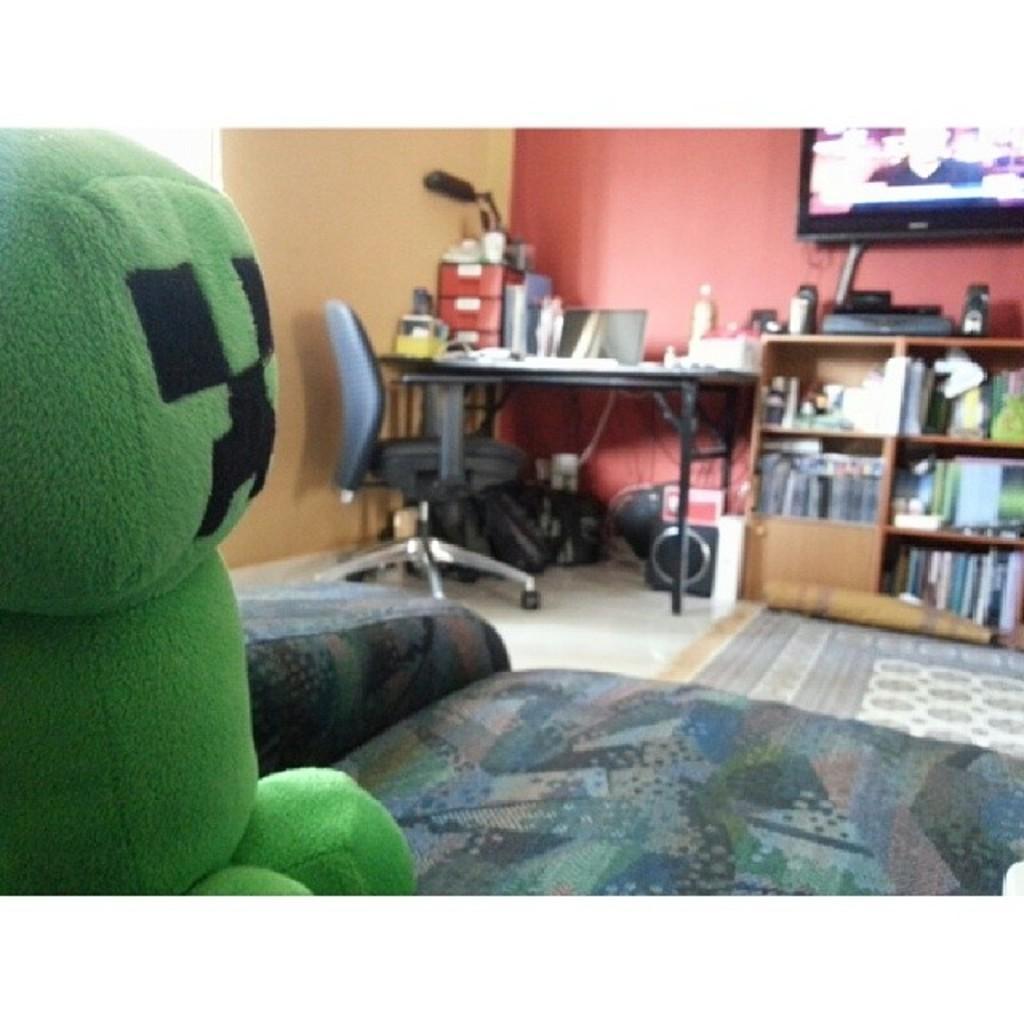How would you summarize this image in a sentence or two? In this picture we can see a room with sofa, toy, table, chair, racks with books in it, television to wall and on table we have some items. 